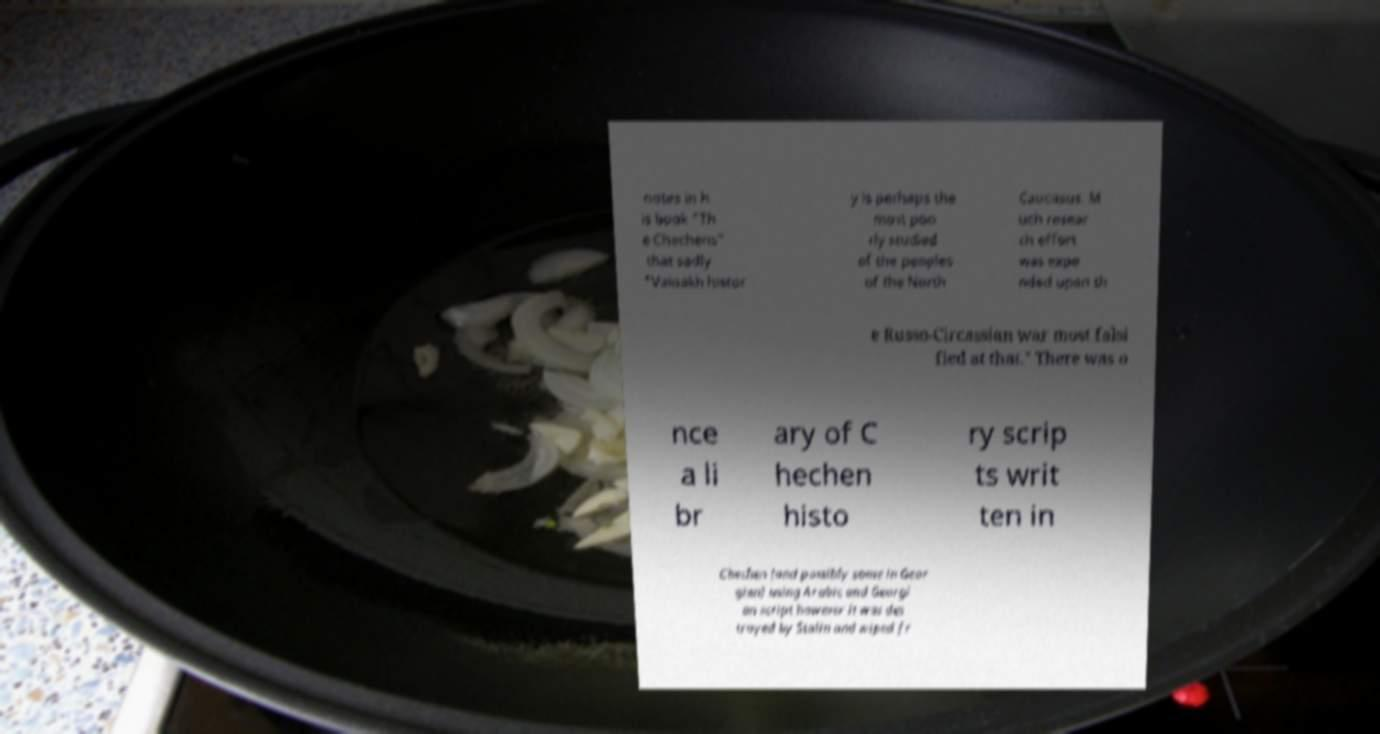Please read and relay the text visible in this image. What does it say? notes in h is book "Th e Chechens" that sadly "Vainakh histor y is perhaps the most poo rly studied of the peoples of the North Caucasus. M uch resear ch effort was expe nded upon th e Russo-Circassian war most falsi fied at that." There was o nce a li br ary of C hechen histo ry scrip ts writ ten in Chechen (and possibly some in Geor gian) using Arabic and Georgi an script however it was des troyed by Stalin and wiped fr 